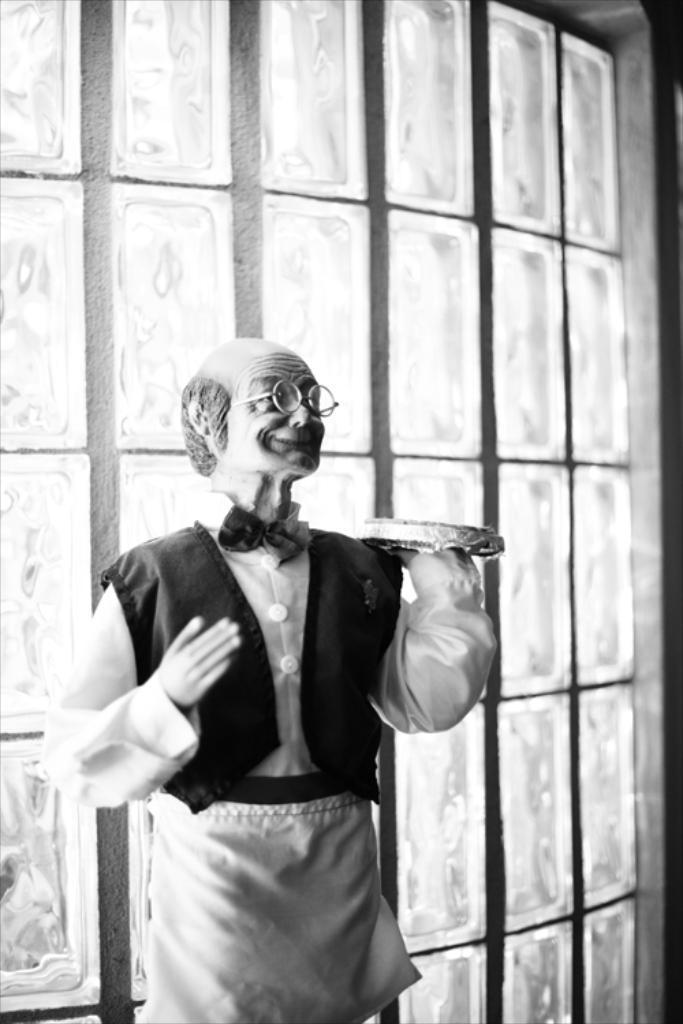In one or two sentences, can you explain what this image depicts? In the center of the image we can see a statue of a man. In the background there is a wall. 